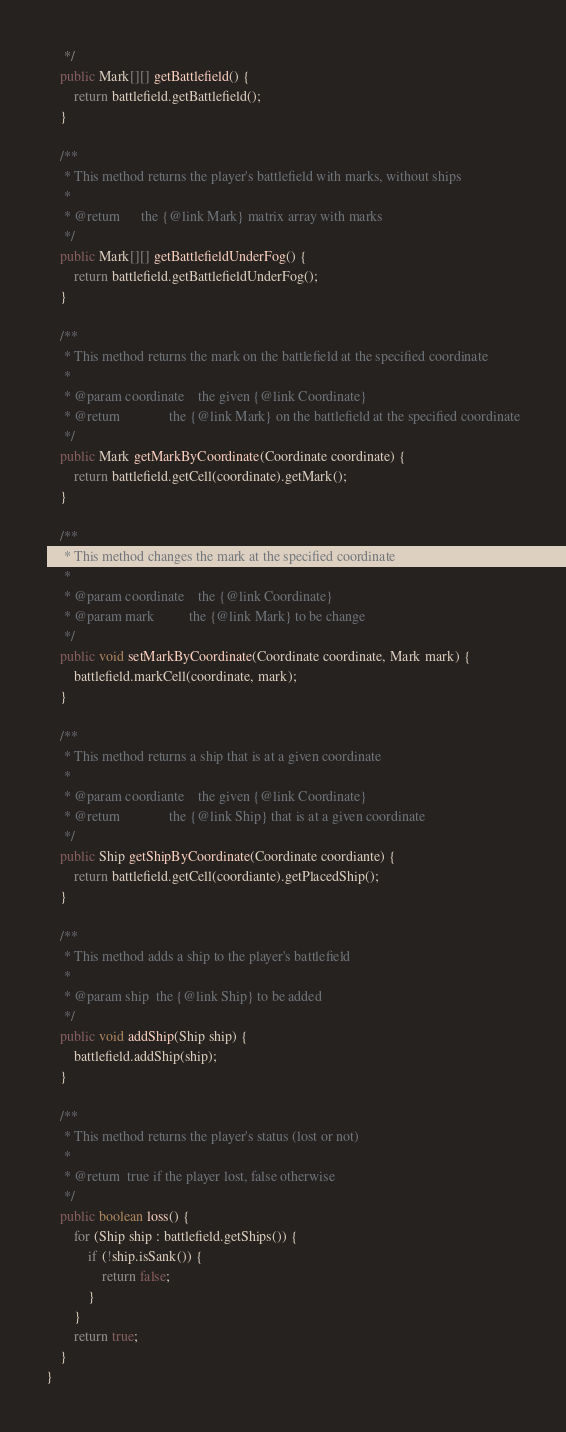<code> <loc_0><loc_0><loc_500><loc_500><_Java_>     */
    public Mark[][] getBattlefield() {
        return battlefield.getBattlefield();
    }

    /**
     * This method returns the player's battlefield with marks, without ships
     *
     * @return		the {@link Mark} matrix array with marks
     */
    public Mark[][] getBattlefieldUnderFog() {
        return battlefield.getBattlefieldUnderFog();
    }

    /**
     * This method returns the mark on the battlefield at the specified coordinate
     *
     * @param coordinate	the given {@link Coordinate}
     * @return				the {@link Mark} on the battlefield at the specified coordinate
     */
    public Mark getMarkByCoordinate(Coordinate coordinate) {
        return battlefield.getCell(coordinate).getMark();
    }

    /**
     * This method changes the mark at the specified coordinate
     *
     * @param coordinate	the {@link Coordinate}
     * @param mark			the {@link Mark} to be change
     */
    public void setMarkByCoordinate(Coordinate coordinate, Mark mark) {
        battlefield.markCell(coordinate, mark);
    }

    /**
     * This method returns a ship that is at a given coordinate
     *
     * @param coordiante	the given {@link Coordinate}
     * @return				the {@link Ship} that is at a given coordinate
     */
    public Ship getShipByCoordinate(Coordinate coordiante) {
        return battlefield.getCell(coordiante).getPlacedShip();
    }

    /**
     * This method adds a ship to the player's battlefield
     *
     * @param ship	the {@link Ship} to be added
     */
    public void addShip(Ship ship) {
        battlefield.addShip(ship);
    }

    /**
     * This method returns the player's status (lost or not)
     *
     * @return	true if the player lost, false otherwise
     */
    public boolean loss() {
        for (Ship ship : battlefield.getShips()) {
            if (!ship.isSank()) {
                return false;
            }
        }
        return true;
    }
}
</code> 